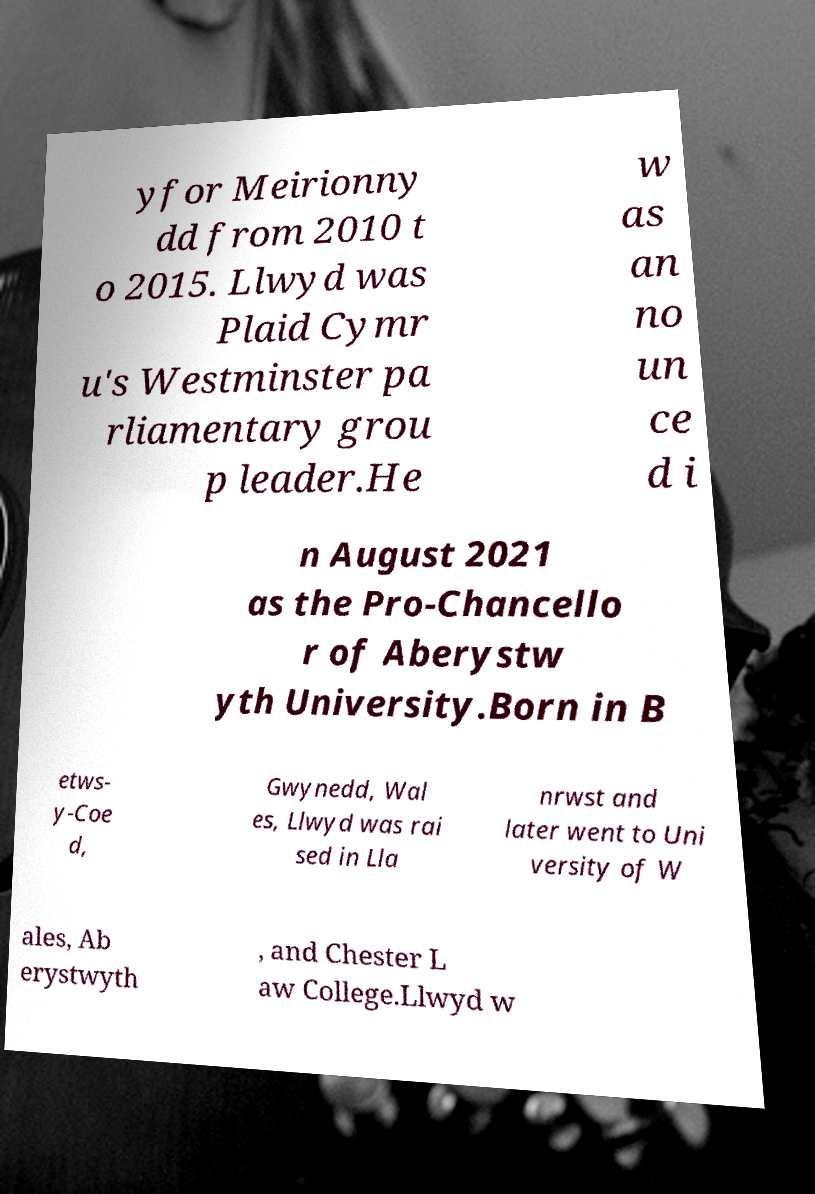Please read and relay the text visible in this image. What does it say? yfor Meirionny dd from 2010 t o 2015. Llwyd was Plaid Cymr u's Westminster pa rliamentary grou p leader.He w as an no un ce d i n August 2021 as the Pro-Chancello r of Aberystw yth University.Born in B etws- y-Coe d, Gwynedd, Wal es, Llwyd was rai sed in Lla nrwst and later went to Uni versity of W ales, Ab erystwyth , and Chester L aw College.Llwyd w 